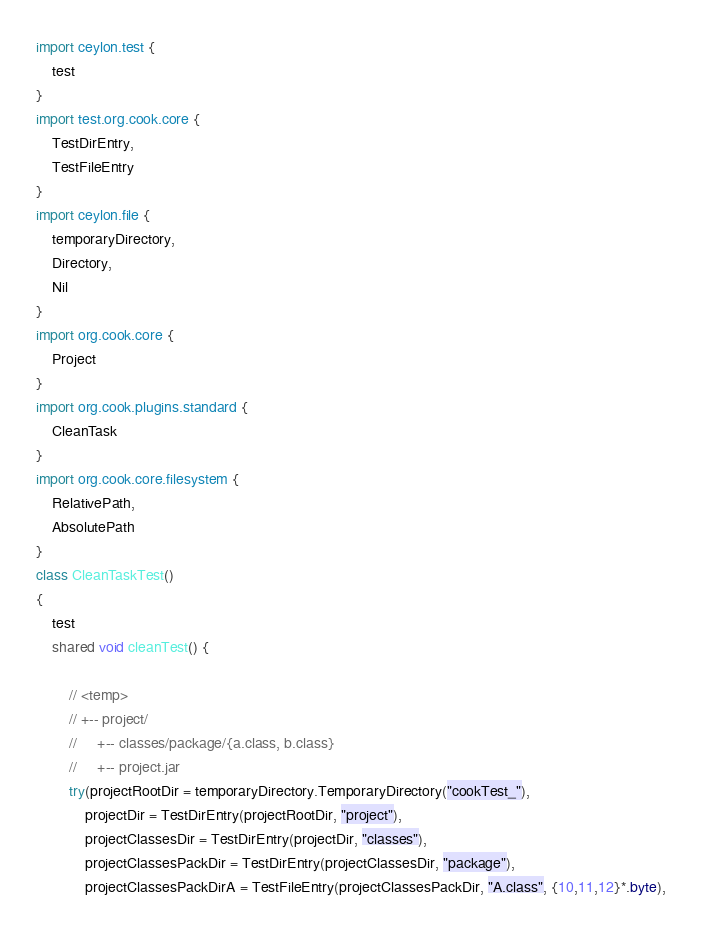Convert code to text. <code><loc_0><loc_0><loc_500><loc_500><_Ceylon_>import ceylon.test {
	test
}
import test.org.cook.core {
	TestDirEntry,
	TestFileEntry
}
import ceylon.file {
	temporaryDirectory,
	Directory,
	Nil
}
import org.cook.core {
	Project
}
import org.cook.plugins.standard {
	CleanTask
}
import org.cook.core.filesystem {
	RelativePath,
	AbsolutePath
}
class CleanTaskTest() 
{
	test
	shared void cleanTest() {
		
		// <temp>
		// +-- project/
		//     +-- classes/package/{a.class, b.class}
		//     +-- project.jar
		try(projectRootDir = temporaryDirectory.TemporaryDirectory("cookTest_"), 
			projectDir = TestDirEntry(projectRootDir, "project"),
			projectClassesDir = TestDirEntry(projectDir, "classes"),
			projectClassesPackDir = TestDirEntry(projectClassesDir, "package"),
			projectClassesPackDirA = TestFileEntry(projectClassesPackDir, "A.class", {10,11,12}*.byte),</code> 